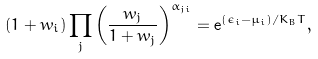Convert formula to latex. <formula><loc_0><loc_0><loc_500><loc_500>( 1 + w _ { i } ) \prod _ { j } \left ( \frac { w _ { j } } { 1 + w _ { j } } \right ) ^ { \alpha _ { j i } } = { \mathrm e } ^ { ( \epsilon _ { i } - \mu _ { i } ) / K _ { B } T } ,</formula> 